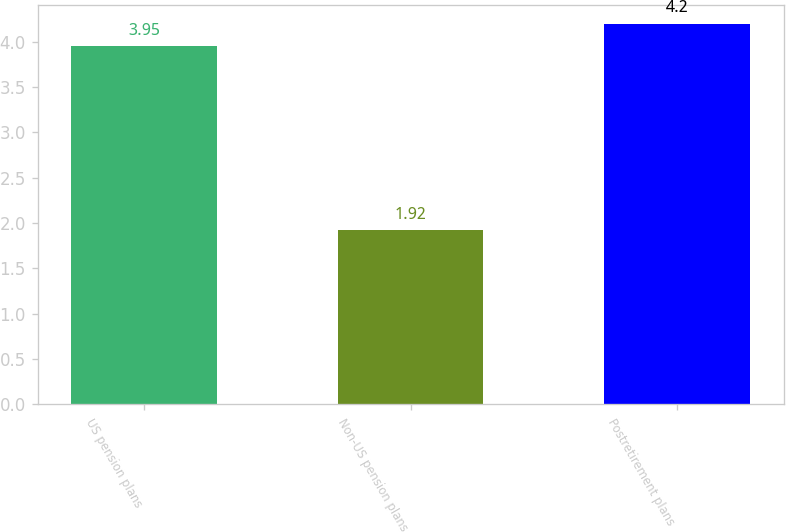Convert chart to OTSL. <chart><loc_0><loc_0><loc_500><loc_500><bar_chart><fcel>US pension plans<fcel>Non-US pension plans<fcel>Postretirement plans<nl><fcel>3.95<fcel>1.92<fcel>4.2<nl></chart> 